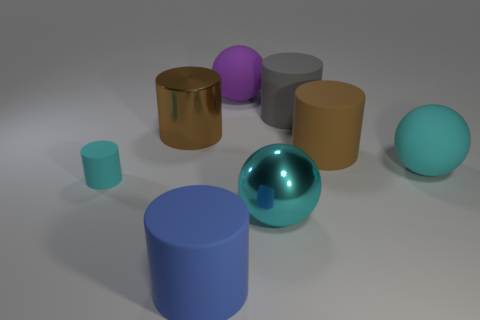Subtract all metal balls. How many balls are left? 2 Add 1 large cyan metallic objects. How many objects exist? 9 Subtract all gray cylinders. How many cylinders are left? 4 Subtract all cylinders. How many objects are left? 3 Subtract all purple cylinders. How many cyan balls are left? 2 Subtract all tiny green balls. Subtract all big brown metallic cylinders. How many objects are left? 7 Add 3 metal things. How many metal things are left? 5 Add 4 tiny red rubber cubes. How many tiny red rubber cubes exist? 4 Subtract 0 yellow blocks. How many objects are left? 8 Subtract 1 spheres. How many spheres are left? 2 